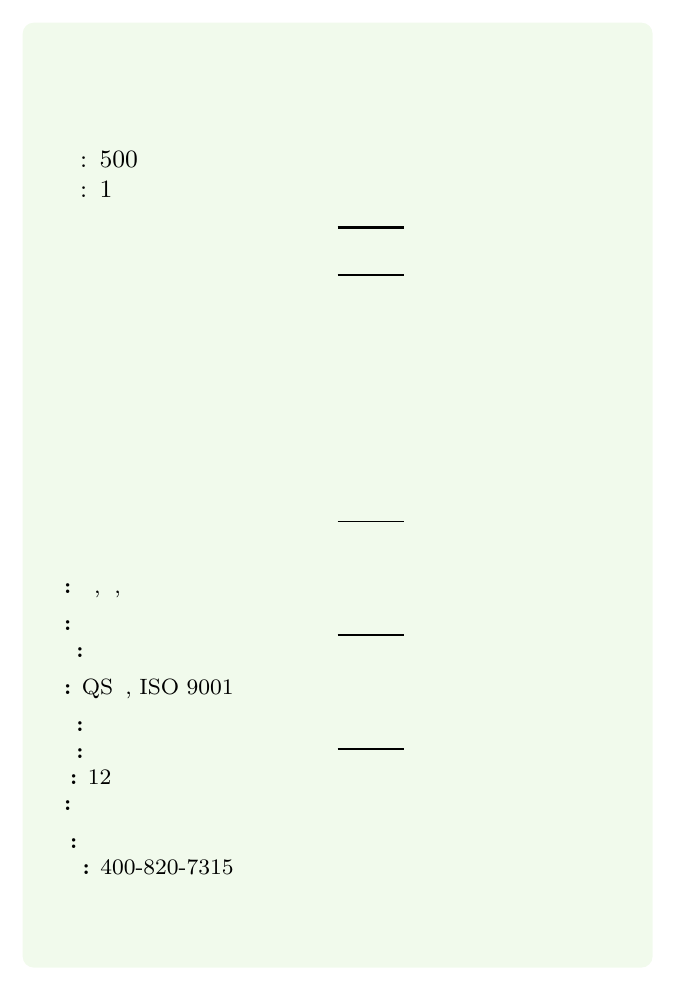How many milligrams of caffeine are in the 统一绿茶 per container? The Nutrition Facts table lists "咖啡因" as 28毫克.
Answer: 28毫克 What is the serving size of 统一绿茶? The serving size section lists "每份含量: 500毫升".
Answer: 500毫升 How much vitamin C is present in the green tea as a percentage? The Nutrition Facts table indicates "维生素C" as 2%.
Answer: 2% What is the total amount of catechins in the tea? The Nutrition Facts table under "抗氧化物" lists "儿茶素" as 90毫克.
Answer: 90毫克 Where is the origin of the tea? The document mentions “产地: 江苏省昆山市”.
Answer: 江苏省昆山市 What is the main ingredient of the tea? A. 水 B. 茶多酚 C. 绿茶 D. 糖 The ingredients list starts with "绿茶", indicating it is the main ingredient.
Answer: C. 绿茶 How much total carbohydrate is in the tea? A. 0克 B. 0.5克 C. 1克 D. 2克 The Nutrition Facts table lists "总碳水化合物" as 0.5克.
Answer: B. 0.5克 Is there any sugar in 统一绿茶? (Yes/No) The Nutrition Facts table under "糖" lists it as 0克.
Answer: No Describe the additional information provided about the tea. The "additional info" section of the document provides details about the tea source, brewing method, shelf life, recyclability, certifications, and manufacturer.
Answer: The tea is sourced from 安徽黄山 and made using a cold brew process. It has a shelf life of 12 months, and the bottle is recyclable. Certified with QS and ISO 9001. Manufacturer: 统一企业中国控股有限公司. What is the consumer hotline number for 统一绿茶? The document lists the consumer hotline as “400-820-7315”.
Answer: 400-820-7315 What certifications does the tea have? The document lists certifications as "QS认证, ISO 9001".
Answer: QS认证, ISO 9001 Can you determine the price of 统一绿茶 from this document? The document does not provide any information regarding the price.
Answer: Not enough information What method is recommended for storing the tea? The storage section advises "请置于阴凉干燥处，开启后请尽快饮用".
Answer: 阴凉干燥处，开启后请尽快饮用 